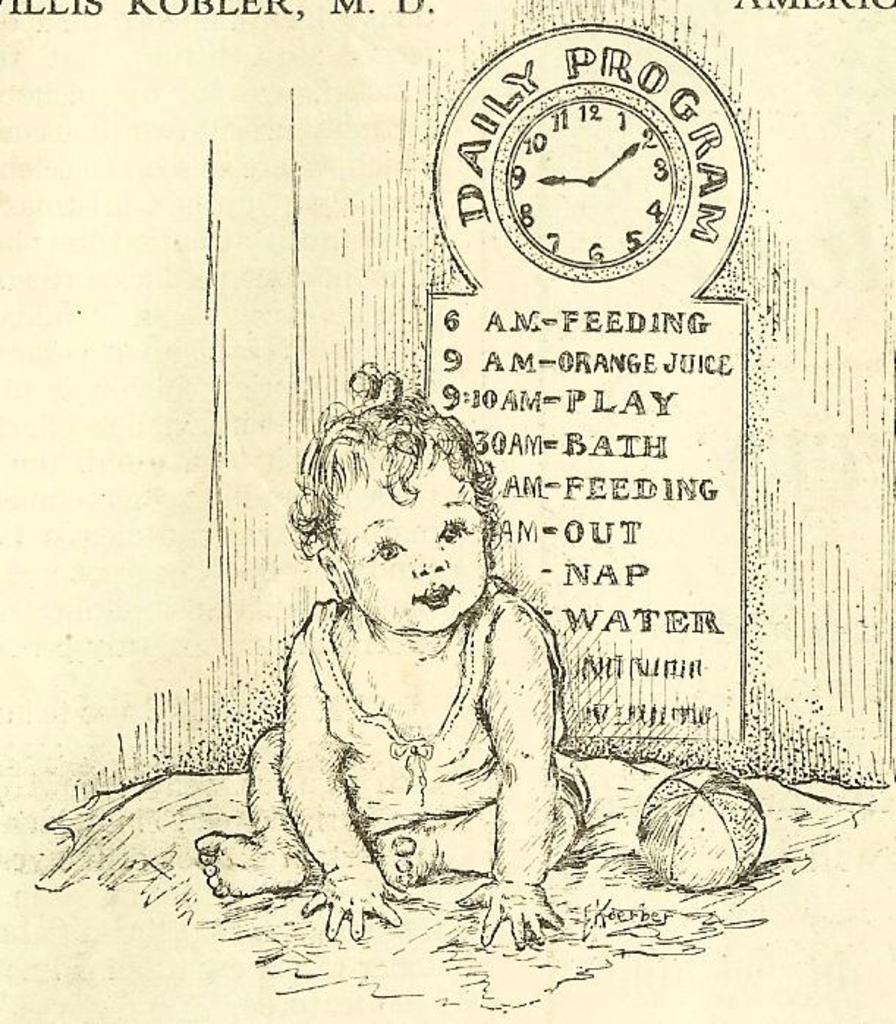What is depicted on the paper in the image? There is a sketch of a child and a sketch of a ball on the paper. What else can be seen on the paper besides the sketches? There is some text in the background of the image. What other objects are present in the image? There is a clock in the background of the image. What type of breakfast is being served in the image? There is no breakfast present in the image; it only features a paper with sketches and a clock in the background. 